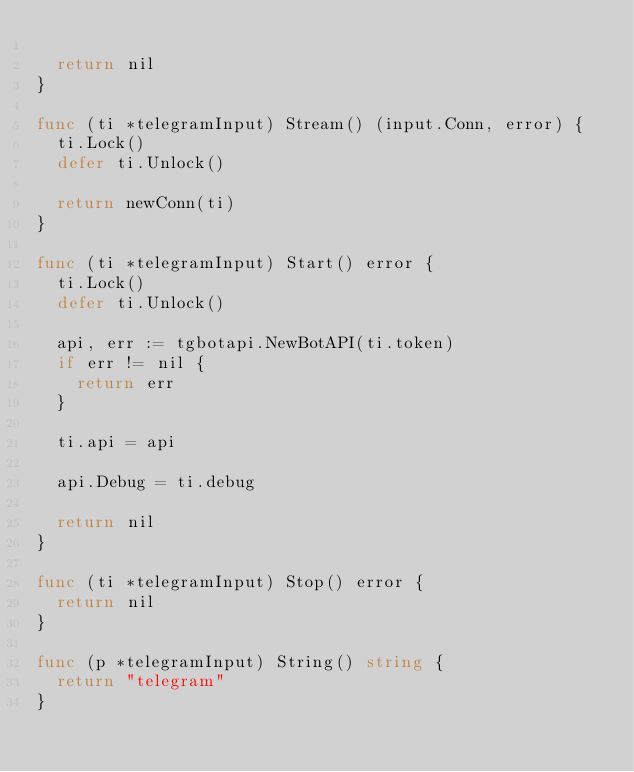<code> <loc_0><loc_0><loc_500><loc_500><_Go_>
	return nil
}

func (ti *telegramInput) Stream() (input.Conn, error) {
	ti.Lock()
	defer ti.Unlock()

	return newConn(ti)
}

func (ti *telegramInput) Start() error {
	ti.Lock()
	defer ti.Unlock()

	api, err := tgbotapi.NewBotAPI(ti.token)
	if err != nil {
		return err
	}

	ti.api = api

	api.Debug = ti.debug

	return nil
}

func (ti *telegramInput) Stop() error {
	return nil
}

func (p *telegramInput) String() string {
	return "telegram"
}
</code> 